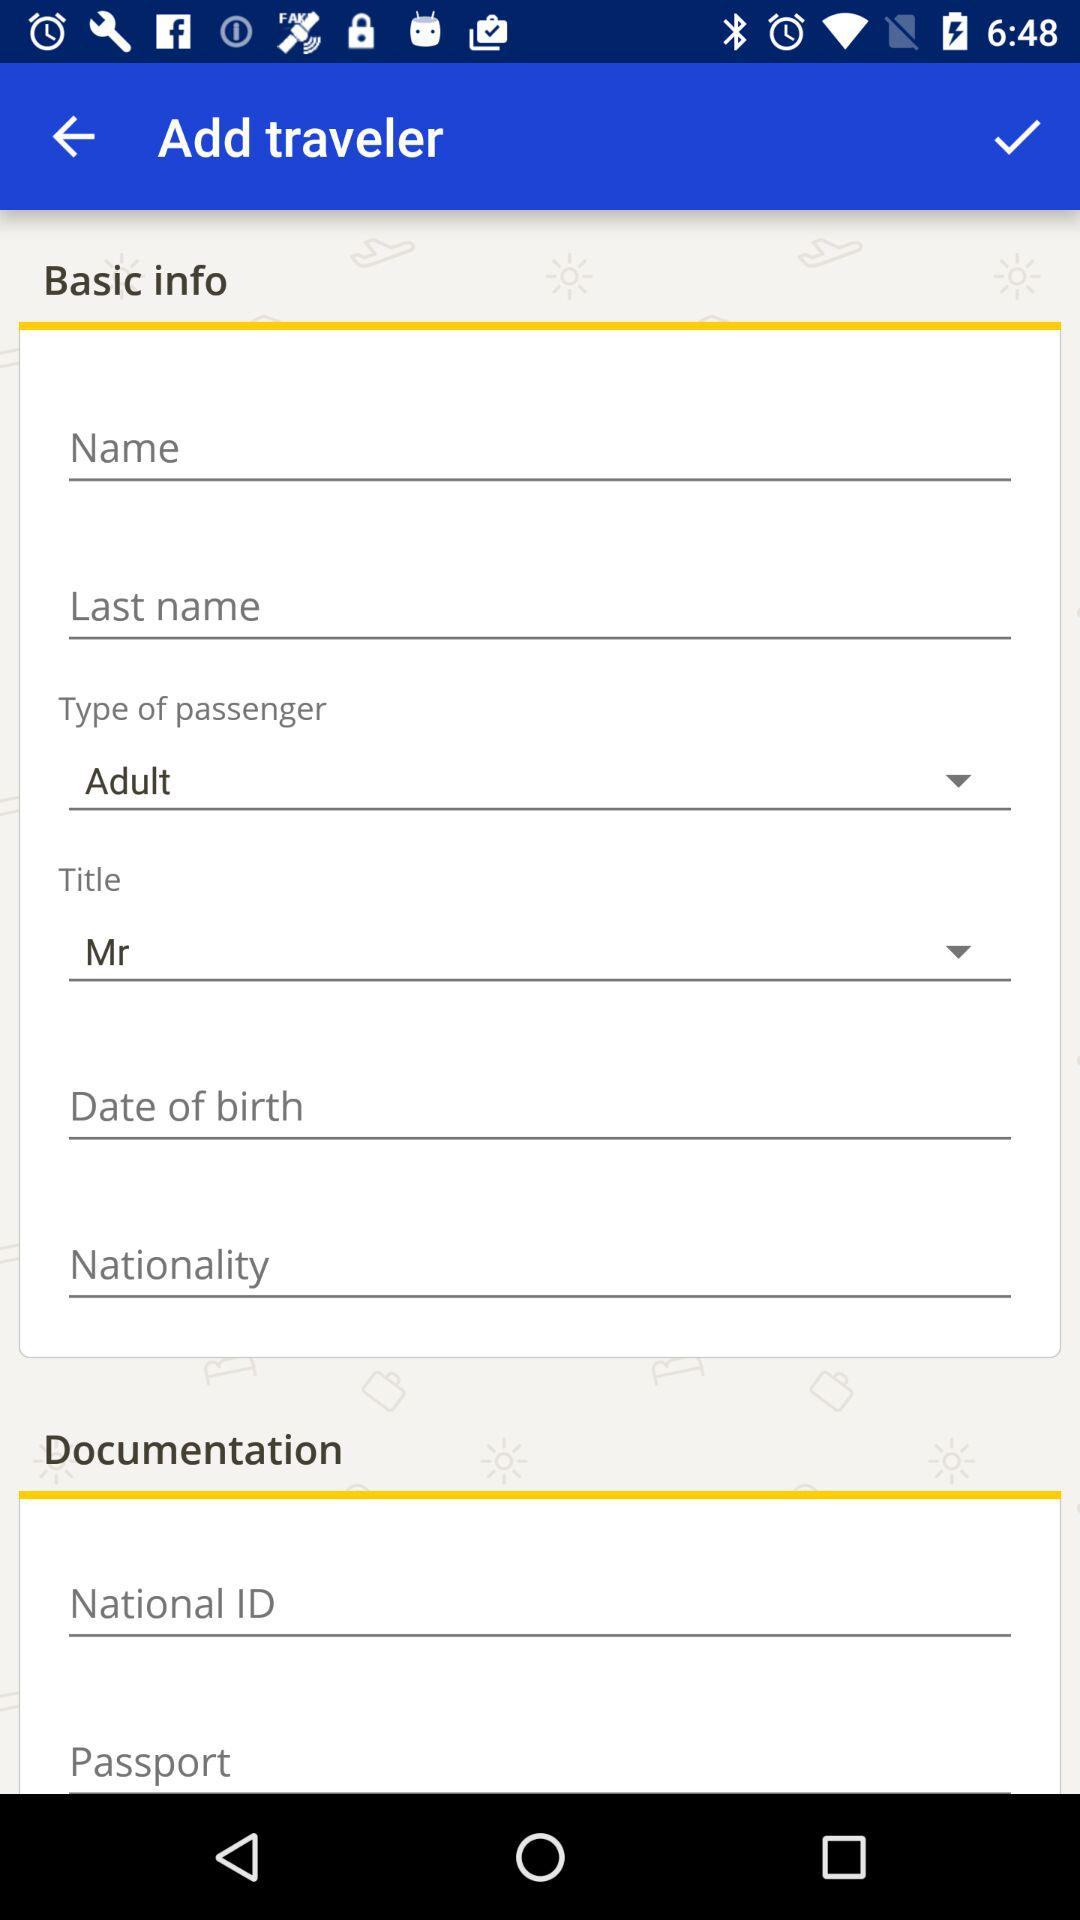What is the selected type of passenger? The selected type of passenger is "Adult". 